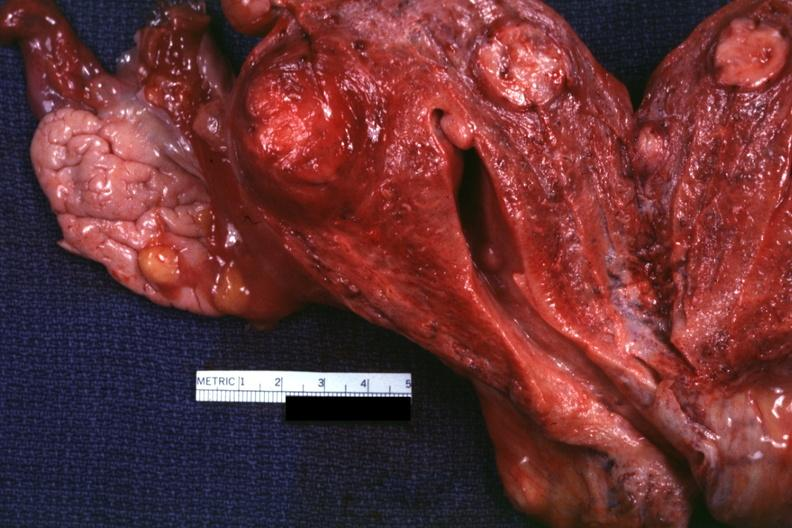s fibrinous peritonitis present?
Answer the question using a single word or phrase. No 